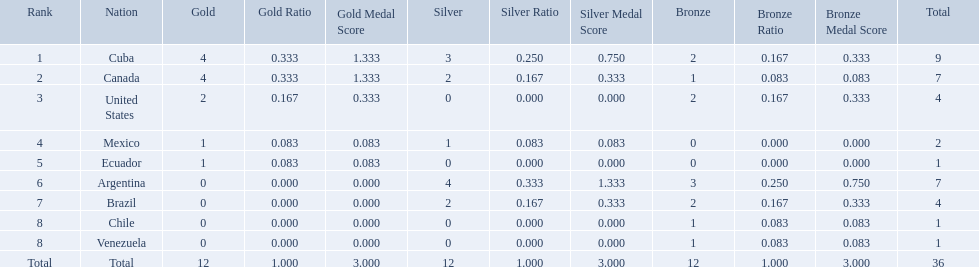What countries participated? Cuba, 4, 3, 2, Canada, 4, 2, 1, United States, 2, 0, 2, Mexico, 1, 1, 0, Ecuador, 1, 0, 0, Argentina, 0, 4, 3, Brazil, 0, 2, 2, Chile, 0, 0, 1, Venezuela, 0, 0, 1. What countries won 1 gold Mexico, 1, 1, 0, Ecuador, 1, 0, 0. What country above also won no silver? Ecuador. Which countries have won gold medals? Cuba, Canada, United States, Mexico, Ecuador. Of these countries, which ones have never won silver or bronze medals? United States, Ecuador. Of the two nations listed previously, which one has only won a gold medal? Ecuador. Which countries won medals at the 2011 pan american games for the canoeing event? Cuba, Canada, United States, Mexico, Ecuador, Argentina, Brazil, Chile, Venezuela. Which of these countries won bronze medals? Cuba, Canada, United States, Argentina, Brazil, Chile, Venezuela. Could you help me parse every detail presented in this table? {'header': ['Rank', 'Nation', 'Gold', 'Gold Ratio', 'Gold Medal Score', 'Silver', 'Silver Ratio', 'Silver Medal Score', 'Bronze', 'Bronze Ratio', 'Bronze Medal Score', 'Total'], 'rows': [['1', 'Cuba', '4', '0.333', '1.333', '3', '0.250', '0.750', '2', '0.167', '0.333', '9'], ['2', 'Canada', '4', '0.333', '1.333', '2', '0.167', '0.333', '1', '0.083', '0.083', '7'], ['3', 'United States', '2', '0.167', '0.333', '0', '0.000', '0.000', '2', '0.167', '0.333', '4'], ['4', 'Mexico', '1', '0.083', '0.083', '1', '0.083', '0.083', '0', '0.000', '0.000', '2'], ['5', 'Ecuador', '1', '0.083', '0.083', '0', '0.000', '0.000', '0', '0.000', '0.000', '1'], ['6', 'Argentina', '0', '0.000', '0.000', '4', '0.333', '1.333', '3', '0.250', '0.750', '7'], ['7', 'Brazil', '0', '0.000', '0.000', '2', '0.167', '0.333', '2', '0.167', '0.333', '4'], ['8', 'Chile', '0', '0.000', '0.000', '0', '0.000', '0.000', '1', '0.083', '0.083', '1'], ['8', 'Venezuela', '0', '0.000', '0.000', '0', '0.000', '0.000', '1', '0.083', '0.083', '1'], ['Total', 'Total', '12', '1.000', '3.000', '12', '1.000', '3.000', '12', '1.000', '3.000', '36']]} Of these countries, which won the most bronze medals? Argentina. 